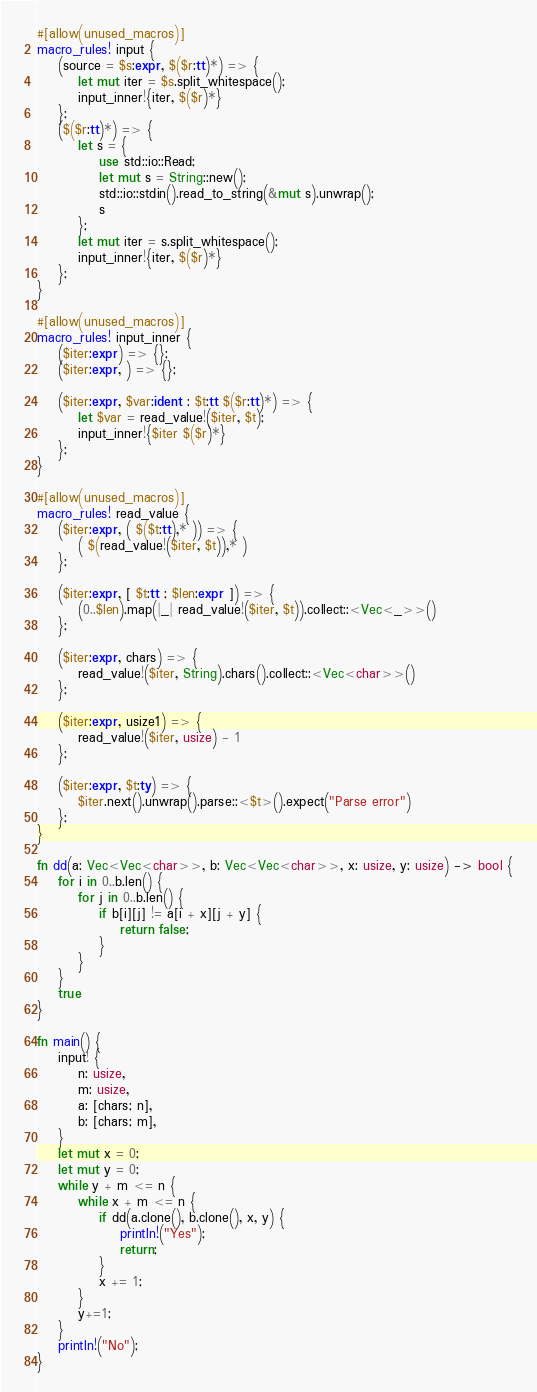<code> <loc_0><loc_0><loc_500><loc_500><_Rust_>#[allow(unused_macros)]
macro_rules! input {
    (source = $s:expr, $($r:tt)*) => {
        let mut iter = $s.split_whitespace();
        input_inner!{iter, $($r)*}
    };
    ($($r:tt)*) => {
        let s = {
            use std::io::Read;
            let mut s = String::new();
            std::io::stdin().read_to_string(&mut s).unwrap();
            s
        };
        let mut iter = s.split_whitespace();
        input_inner!{iter, $($r)*}
    };
}

#[allow(unused_macros)]
macro_rules! input_inner {
    ($iter:expr) => {};
    ($iter:expr, ) => {};

    ($iter:expr, $var:ident : $t:tt $($r:tt)*) => {
        let $var = read_value!($iter, $t);
        input_inner!{$iter $($r)*}
    };
}

#[allow(unused_macros)]
macro_rules! read_value {
    ($iter:expr, ( $($t:tt),* )) => {
        ( $(read_value!($iter, $t)),* )
    };

    ($iter:expr, [ $t:tt ; $len:expr ]) => {
        (0..$len).map(|_| read_value!($iter, $t)).collect::<Vec<_>>()
    };

    ($iter:expr, chars) => {
        read_value!($iter, String).chars().collect::<Vec<char>>()
    };

    ($iter:expr, usize1) => {
        read_value!($iter, usize) - 1
    };

    ($iter:expr, $t:ty) => {
        $iter.next().unwrap().parse::<$t>().expect("Parse error")
    };
}

fn dd(a: Vec<Vec<char>>, b: Vec<Vec<char>>, x: usize, y: usize) -> bool {
    for i in 0..b.len() {
        for j in 0..b.len() {
            if b[i][j] != a[i + x][j + y] {
                return false;
            }
        }
    }
    true
}

fn main() {
    input! {
        n: usize,
        m: usize,
        a: [chars; n],
        b: [chars; m],
    }
    let mut x = 0;
    let mut y = 0;
    while y + m <= n {
        while x + m <= n {
            if dd(a.clone(), b.clone(), x, y) {
                println!("Yes");
                return;
            }
            x += 1;
        }
        y+=1;
    }
    println!("No");
}</code> 